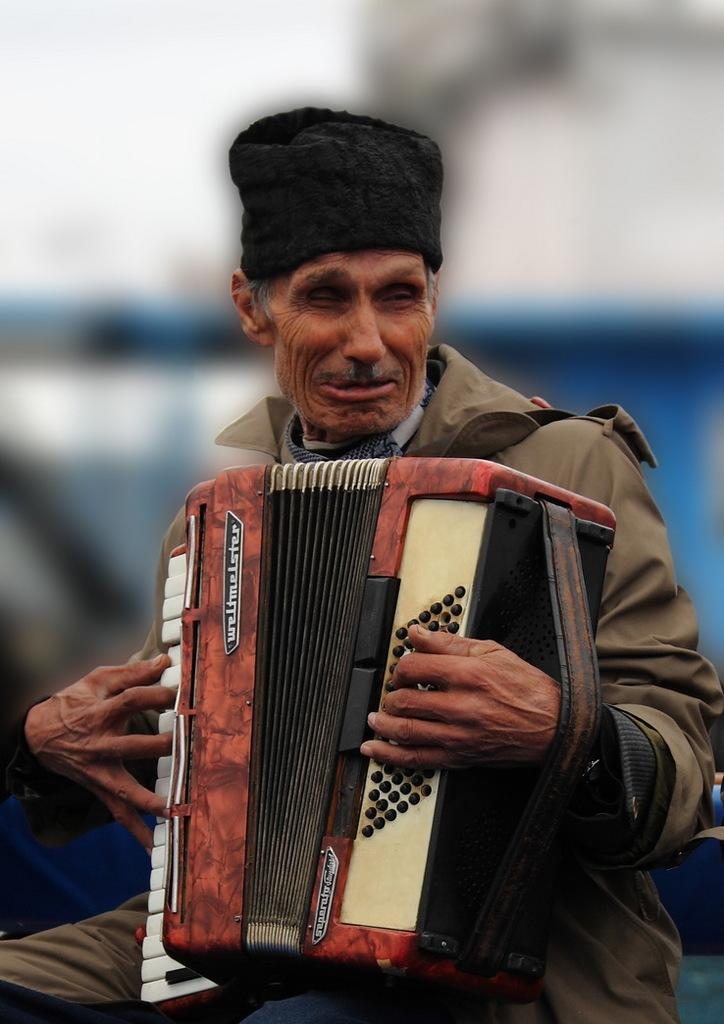What is happening with the person in the image? The person is crying and playing a music instrument. Can you describe the background of the image? The background of the image has a blurred view. What colors can be seen in the image? The colors white and blue are present in the image. What type of doll is the person playing with in the image? There is no doll present in the image; the person is playing a music instrument. What activity is the man in the image participating in? The image does not specify the person's gender, and there is no activity mentioned other than playing a music instrument and crying. 